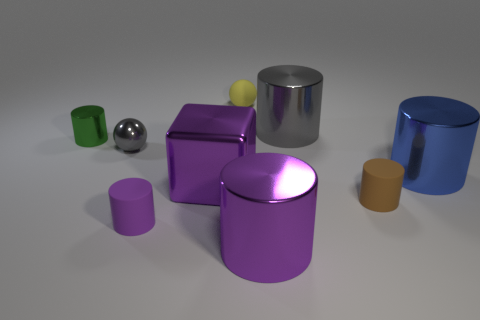Subtract all small green cylinders. How many cylinders are left? 5 Subtract all yellow cubes. How many purple cylinders are left? 2 Subtract all gray cylinders. How many cylinders are left? 5 Subtract all spheres. How many objects are left? 7 Add 1 large purple rubber things. How many objects exist? 10 Subtract 1 cylinders. How many cylinders are left? 5 Add 7 tiny green metal objects. How many tiny green metal objects are left? 8 Add 4 big brown rubber things. How many big brown rubber things exist? 4 Subtract 0 gray blocks. How many objects are left? 9 Subtract all red cylinders. Subtract all blue spheres. How many cylinders are left? 6 